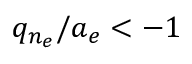<formula> <loc_0><loc_0><loc_500><loc_500>q _ { n _ { e } } / a _ { e } < - 1</formula> 